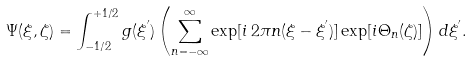<formula> <loc_0><loc_0><loc_500><loc_500>\Psi ( \xi , \zeta ) = \int _ { - 1 / 2 } ^ { + 1 / 2 } g ( \xi ^ { ^ { \prime } } ) \left ( \sum _ { n = - \infty } ^ { \infty } \exp [ i \, 2 \pi n ( \xi - \xi ^ { ^ { \prime } } ) ] \exp [ i \Theta _ { n } ( \zeta ) ] \right ) d \xi ^ { ^ { \prime } } .</formula> 